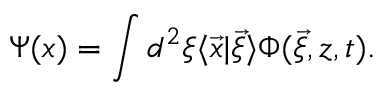Convert formula to latex. <formula><loc_0><loc_0><loc_500><loc_500>\Psi ( x ) = \int d ^ { 2 } \xi \langle \vec { x } | \vec { \xi } \rangle \Phi ( \vec { \xi } , z , t ) .</formula> 